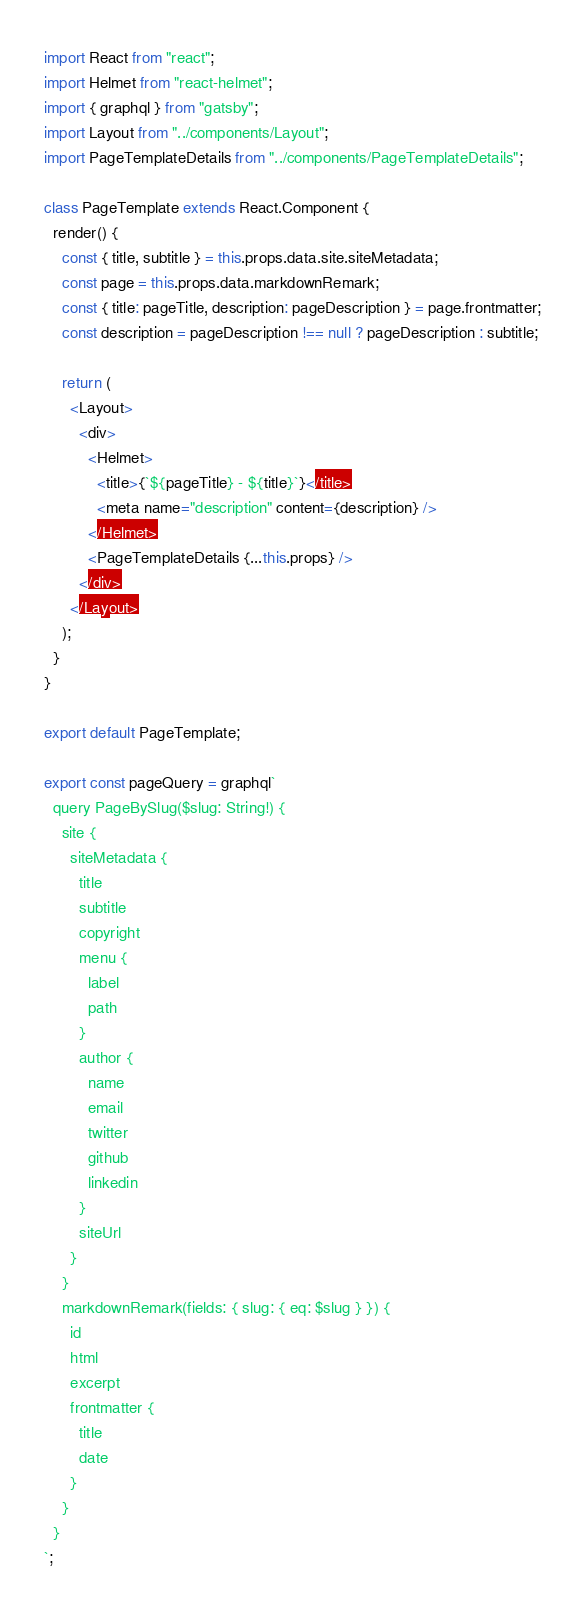<code> <loc_0><loc_0><loc_500><loc_500><_JavaScript_>import React from "react";
import Helmet from "react-helmet";
import { graphql } from "gatsby";
import Layout from "../components/Layout";
import PageTemplateDetails from "../components/PageTemplateDetails";

class PageTemplate extends React.Component {
  render() {
    const { title, subtitle } = this.props.data.site.siteMetadata;
    const page = this.props.data.markdownRemark;
    const { title: pageTitle, description: pageDescription } = page.frontmatter;
    const description = pageDescription !== null ? pageDescription : subtitle;

    return (
      <Layout>
        <div>
          <Helmet>
            <title>{`${pageTitle} - ${title}`}</title>
            <meta name="description" content={description} />
          </Helmet>
          <PageTemplateDetails {...this.props} />
        </div>
      </Layout>
    );
  }
}

export default PageTemplate;

export const pageQuery = graphql`
  query PageBySlug($slug: String!) {
    site {
      siteMetadata {
        title
        subtitle
        copyright
        menu {
          label
          path
        }
        author {
          name
          email
          twitter
          github
          linkedin
        }
        siteUrl
      }
    }
    markdownRemark(fields: { slug: { eq: $slug } }) {
      id
      html
      excerpt
      frontmatter {
        title
        date
      }
    }
  }
`;
</code> 